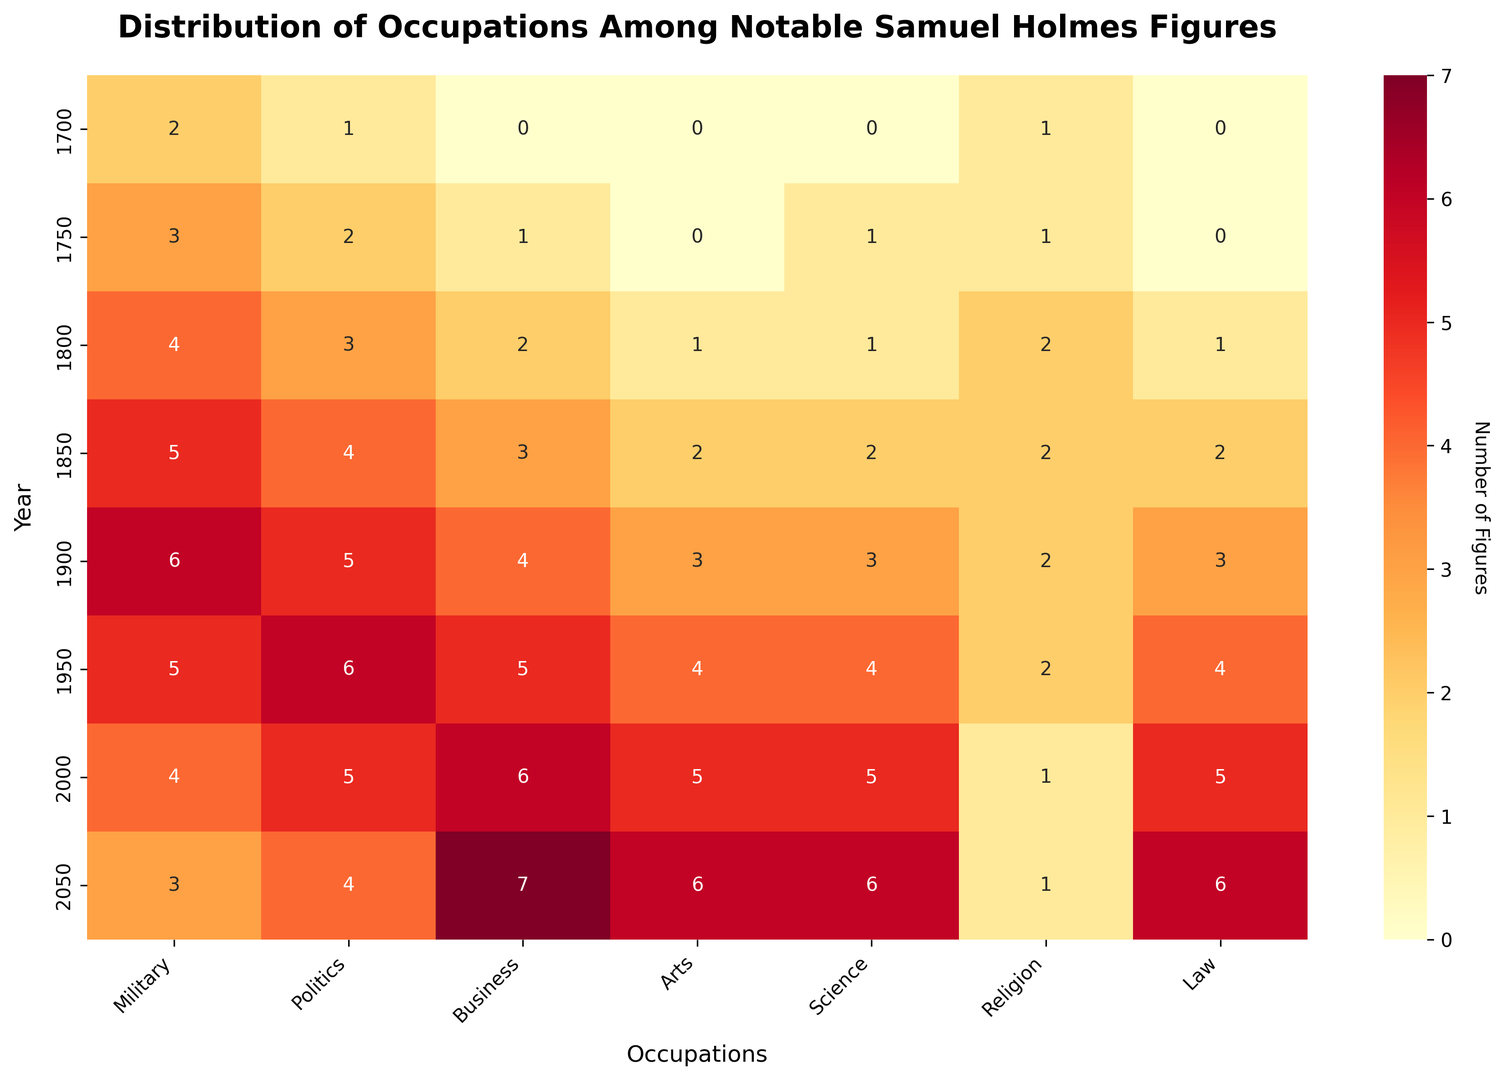What's the most common occupation of notable Samuel Holmes figures in 2000? In the heatmap, look at the row corresponding to the year 2000 and identify the column with the highest value. The occupation 'Law' has the highest value (5).
Answer: Law How did the number of Samuel Holmes in politics change from 1700 to 1900? Compare the political figures in 1700 (1) to those in 1900 (5). The change is calculated as 5 - 1.
Answer: Increased by 4 Which year has the least number of notable Samuel Holmes in the military? Scan the "Military" column and identify the smallest number. The year 1700 has the smallest value (2) for military.
Answer: 1700 What's the average number of notable Samuel Holmes in arts across all years? Sum the values in the "Arts" column and divide by the number of data points (0 + 0 + 1 + 2 + 3 + 4 + 5 + 6) / 8 = 21 / 8 = 2.625.
Answer: 2.625 Which occupation had the greatest increase in notable Samuel Holmes from 1800 to 1950? Calculate the differences in the values for each occupation from 1800 to 1950: Military (1), Politics (3), Business (3), Arts (3), Science (3), Religion (0), Law (3). The greatest is Politics (3).
Answer: Politics How did the number of notable Samuel Holmes in religion change from 1900 to 2050? Compare the values in the "Religion" column for 1900 and 2050. It decreased from 2 to 1.
Answer: Decreased by 1 Which occupation saw a decline between 1950 and 2050? Look for occupations where the number decreases from 1950 to 2050 values. Both Military (5 to 3) and Religion (2 to 1) show a decline.
Answer: Military and Religion Which year has the most significant representation in Science? Scan the "Science" column and find the highest value (6), which corresponds to the year 2050.
Answer: 2050 In what year did the number of notable Samuel Holmes in law first become 3 or more? Look for the first occurrence in the "Law" column with a value of 3 or greater (3 in 1900).
Answer: 1900 